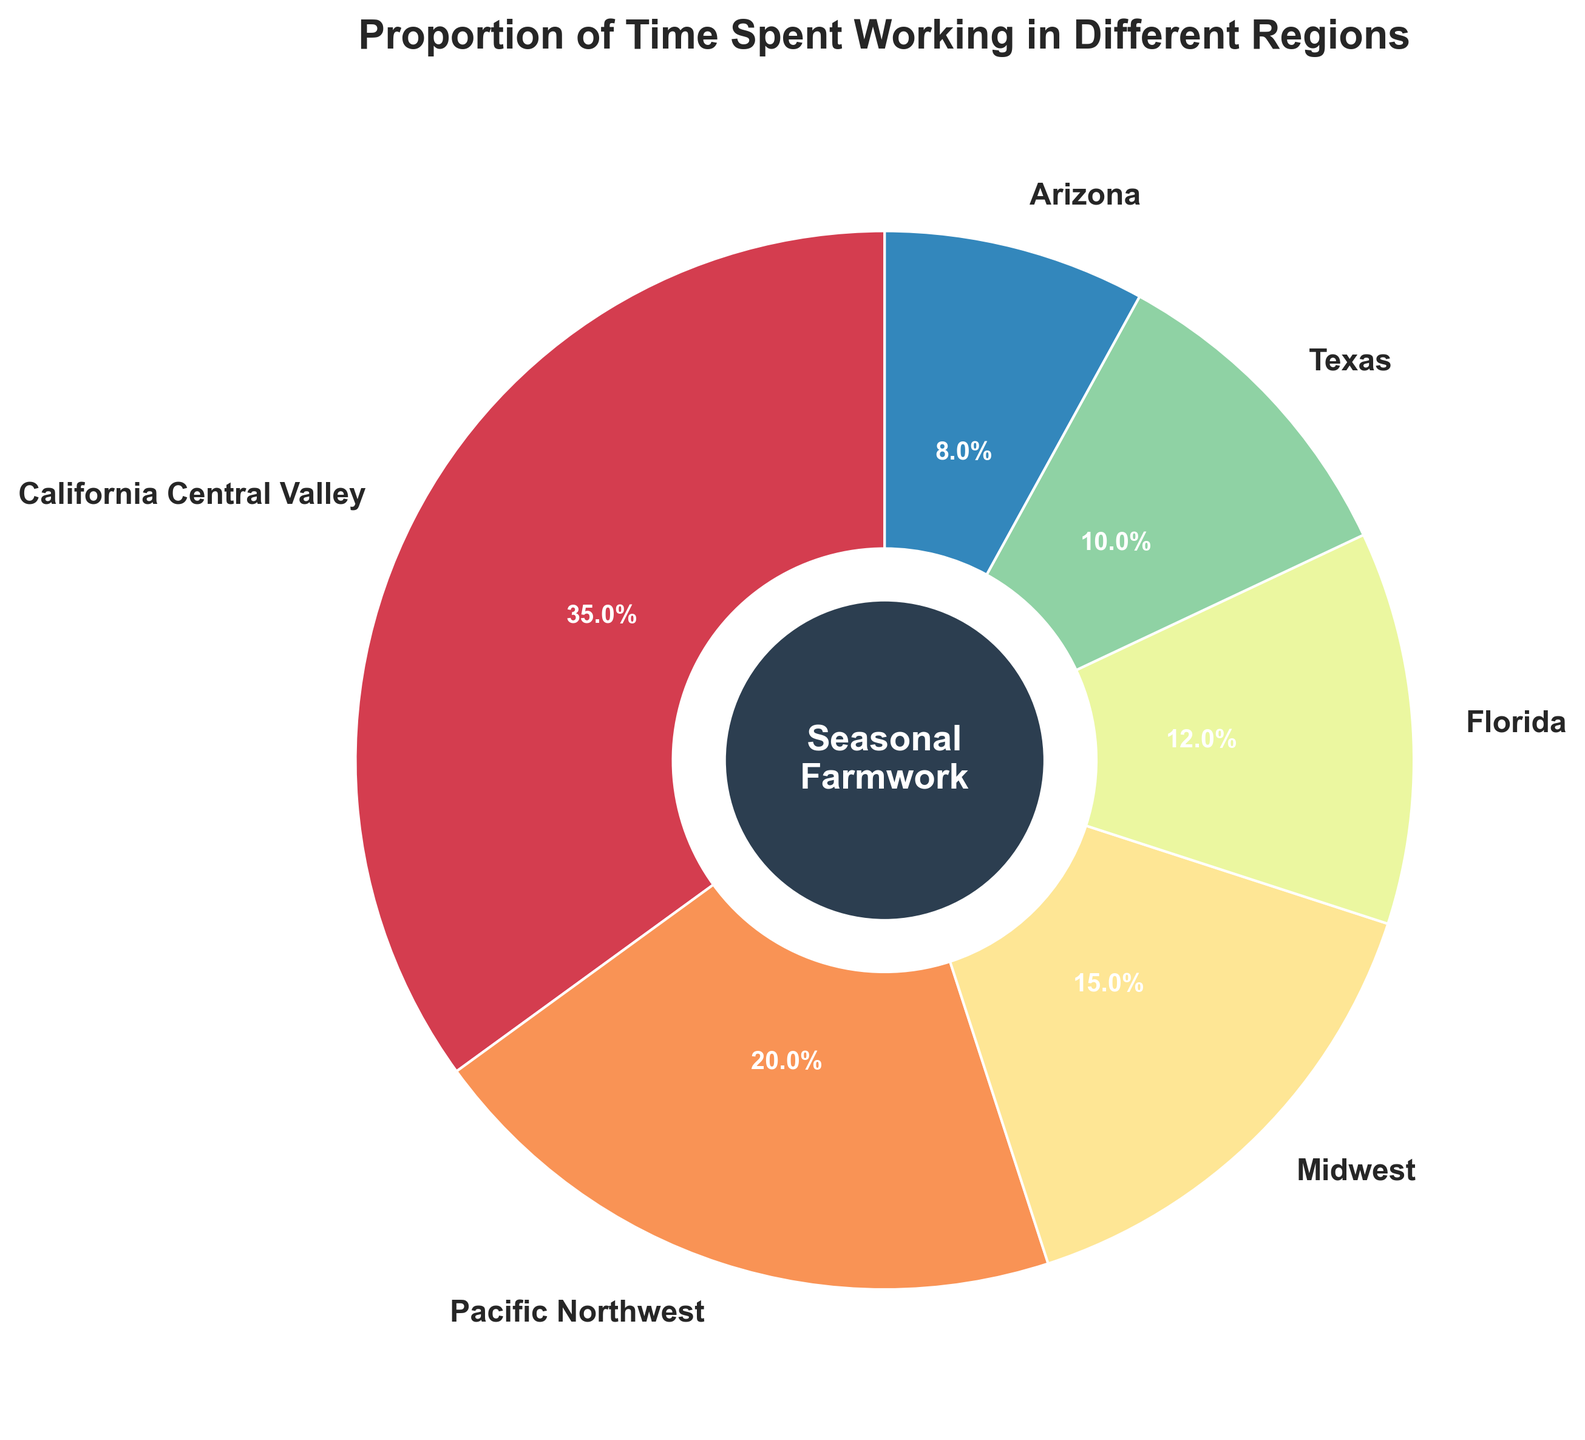What proportion of time do we spend working in California Central Valley and Texas combined? The figure shows that we spend 35% of our time in California Central Valley and 10% in Texas. Adding these together: 35% + 10% = 45%.
Answer: 45% Which region do we spend the least time in? In the figure, Arizona is shown with 8%, which is the smallest proportion compared to other regions.
Answer: Arizona Is the proportion of time spent in the Pacific Northwest greater than in the Midwest? The figure shows that the proportion of time spent in the Pacific Northwest is 20%, whereas in the Midwest it is 15%. Since 20% is greater than 15%, the answer is yes.
Answer: Yes Compare the proportion of time spent in Florida to Texas. Which is greater and by how much? The figure indicates that Florida has 12% and Texas has 10%. The difference between these is 12% - 10% = 2%. Since 12% is greater than 10%, Florida has a 2% higher proportion.
Answer: Florida by 2% What is the total proportion of time spent in Midwest, Florida, and Arizona? The figure shows that the time spent in the Midwest is 15%, in Florida is 12%, and in Arizona is 8%. Adding these together: 15% + 12% + 8% = 35%.
Answer: 35% Which region takes up a larger share of time: Pacific Northwest or Arizona? In the figure, the Pacific Northwest has a proportion of 20%, while Arizona has a proportion of 8%. Since 20% is greater than 8%, the Pacific Northwest takes up a larger share of time.
Answer: Pacific Northwest What is the common wedge color for the region where we spend the most time? The region where we spend the most time is California Central Valley at 35%. The figure uses a color palette, and California Central Valley appears in a specific color. The exact hue can be visually identified when observing the figure.
Answer: (Identify the specific color visually from the figure) Do combined times spent in Texas and Arizona exceed the time spent in California Central Valley? The figure shows that Texas takes up 10% and Arizona takes up 8%, combining these: 10% + 8% = 18%. California Central Valley has a proportion of 35%. Since 18% is less than 35%, the combined times do not exceed.
Answer: No What's the difference between the time spent in Pacific Northwest and Florida? According to the figure, the time spent in the Pacific Northwest is 20% and in Florida is 12%. The difference is calculated as 20% - 12% = 8%.
Answer: 8% How much more time do we spend in the California Central Valley than in the second-highest region? The California Central Valley is at 35%, and the second-highest region is the Pacific Northwest at 20%. The difference between these proportions is 35% - 20% = 15%.
Answer: 15% 